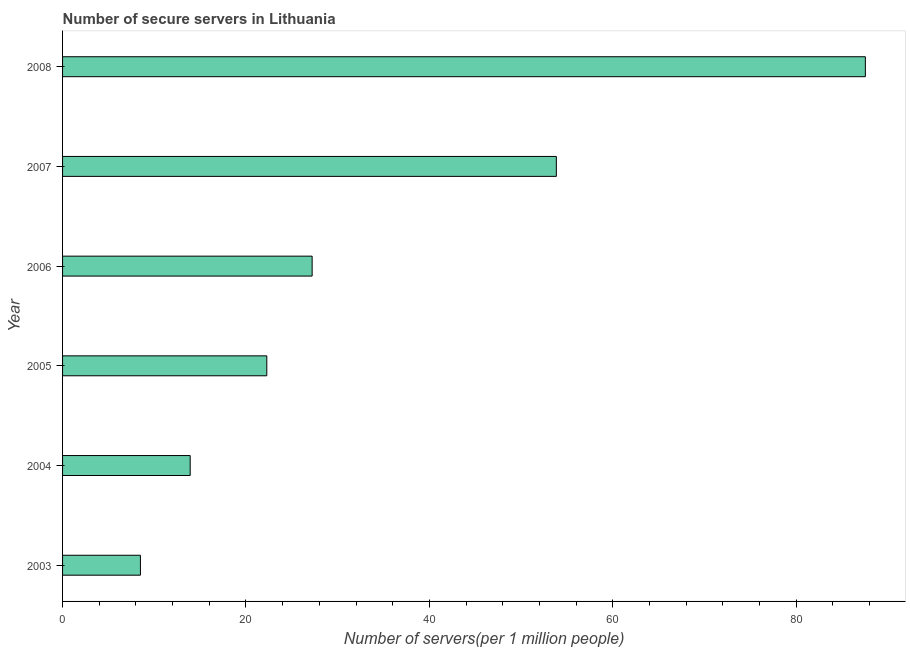Does the graph contain any zero values?
Ensure brevity in your answer.  No. Does the graph contain grids?
Make the answer very short. No. What is the title of the graph?
Your response must be concise. Number of secure servers in Lithuania. What is the label or title of the X-axis?
Make the answer very short. Number of servers(per 1 million people). What is the number of secure internet servers in 2006?
Provide a short and direct response. 27.22. Across all years, what is the maximum number of secure internet servers?
Give a very brief answer. 87.55. Across all years, what is the minimum number of secure internet servers?
Keep it short and to the point. 8.49. In which year was the number of secure internet servers maximum?
Offer a terse response. 2008. In which year was the number of secure internet servers minimum?
Offer a terse response. 2003. What is the sum of the number of secure internet servers?
Ensure brevity in your answer.  213.3. What is the difference between the number of secure internet servers in 2003 and 2008?
Offer a terse response. -79.06. What is the average number of secure internet servers per year?
Make the answer very short. 35.55. What is the median number of secure internet servers?
Make the answer very short. 24.75. In how many years, is the number of secure internet servers greater than 24 ?
Offer a terse response. 3. Do a majority of the years between 2006 and 2005 (inclusive) have number of secure internet servers greater than 72 ?
Keep it short and to the point. No. What is the ratio of the number of secure internet servers in 2003 to that in 2007?
Your answer should be compact. 0.16. Is the difference between the number of secure internet servers in 2007 and 2008 greater than the difference between any two years?
Provide a succinct answer. No. What is the difference between the highest and the second highest number of secure internet servers?
Your answer should be very brief. 33.7. Is the sum of the number of secure internet servers in 2005 and 2008 greater than the maximum number of secure internet servers across all years?
Offer a very short reply. Yes. What is the difference between the highest and the lowest number of secure internet servers?
Ensure brevity in your answer.  79.06. How many bars are there?
Provide a succinct answer. 6. What is the Number of servers(per 1 million people) of 2003?
Provide a short and direct response. 8.49. What is the Number of servers(per 1 million people) in 2004?
Keep it short and to the point. 13.92. What is the Number of servers(per 1 million people) in 2005?
Ensure brevity in your answer.  22.27. What is the Number of servers(per 1 million people) of 2006?
Offer a very short reply. 27.22. What is the Number of servers(per 1 million people) of 2007?
Your answer should be compact. 53.85. What is the Number of servers(per 1 million people) of 2008?
Your response must be concise. 87.55. What is the difference between the Number of servers(per 1 million people) in 2003 and 2004?
Make the answer very short. -5.43. What is the difference between the Number of servers(per 1 million people) in 2003 and 2005?
Offer a very short reply. -13.78. What is the difference between the Number of servers(per 1 million people) in 2003 and 2006?
Your answer should be very brief. -18.73. What is the difference between the Number of servers(per 1 million people) in 2003 and 2007?
Offer a very short reply. -45.36. What is the difference between the Number of servers(per 1 million people) in 2003 and 2008?
Your answer should be compact. -79.06. What is the difference between the Number of servers(per 1 million people) in 2004 and 2005?
Offer a terse response. -8.35. What is the difference between the Number of servers(per 1 million people) in 2004 and 2006?
Your answer should be very brief. -13.3. What is the difference between the Number of servers(per 1 million people) in 2004 and 2007?
Offer a very short reply. -39.93. What is the difference between the Number of servers(per 1 million people) in 2004 and 2008?
Provide a succinct answer. -73.63. What is the difference between the Number of servers(per 1 million people) in 2005 and 2006?
Offer a very short reply. -4.95. What is the difference between the Number of servers(per 1 million people) in 2005 and 2007?
Ensure brevity in your answer.  -31.58. What is the difference between the Number of servers(per 1 million people) in 2005 and 2008?
Offer a terse response. -65.28. What is the difference between the Number of servers(per 1 million people) in 2006 and 2007?
Ensure brevity in your answer.  -26.63. What is the difference between the Number of servers(per 1 million people) in 2006 and 2008?
Keep it short and to the point. -60.33. What is the difference between the Number of servers(per 1 million people) in 2007 and 2008?
Provide a short and direct response. -33.7. What is the ratio of the Number of servers(per 1 million people) in 2003 to that in 2004?
Offer a very short reply. 0.61. What is the ratio of the Number of servers(per 1 million people) in 2003 to that in 2005?
Offer a terse response. 0.38. What is the ratio of the Number of servers(per 1 million people) in 2003 to that in 2006?
Offer a terse response. 0.31. What is the ratio of the Number of servers(per 1 million people) in 2003 to that in 2007?
Provide a succinct answer. 0.16. What is the ratio of the Number of servers(per 1 million people) in 2003 to that in 2008?
Your response must be concise. 0.1. What is the ratio of the Number of servers(per 1 million people) in 2004 to that in 2005?
Provide a short and direct response. 0.62. What is the ratio of the Number of servers(per 1 million people) in 2004 to that in 2006?
Your answer should be compact. 0.51. What is the ratio of the Number of servers(per 1 million people) in 2004 to that in 2007?
Your response must be concise. 0.26. What is the ratio of the Number of servers(per 1 million people) in 2004 to that in 2008?
Your response must be concise. 0.16. What is the ratio of the Number of servers(per 1 million people) in 2005 to that in 2006?
Your response must be concise. 0.82. What is the ratio of the Number of servers(per 1 million people) in 2005 to that in 2007?
Your answer should be very brief. 0.41. What is the ratio of the Number of servers(per 1 million people) in 2005 to that in 2008?
Provide a short and direct response. 0.25. What is the ratio of the Number of servers(per 1 million people) in 2006 to that in 2007?
Your response must be concise. 0.51. What is the ratio of the Number of servers(per 1 million people) in 2006 to that in 2008?
Your answer should be very brief. 0.31. What is the ratio of the Number of servers(per 1 million people) in 2007 to that in 2008?
Provide a succinct answer. 0.61. 